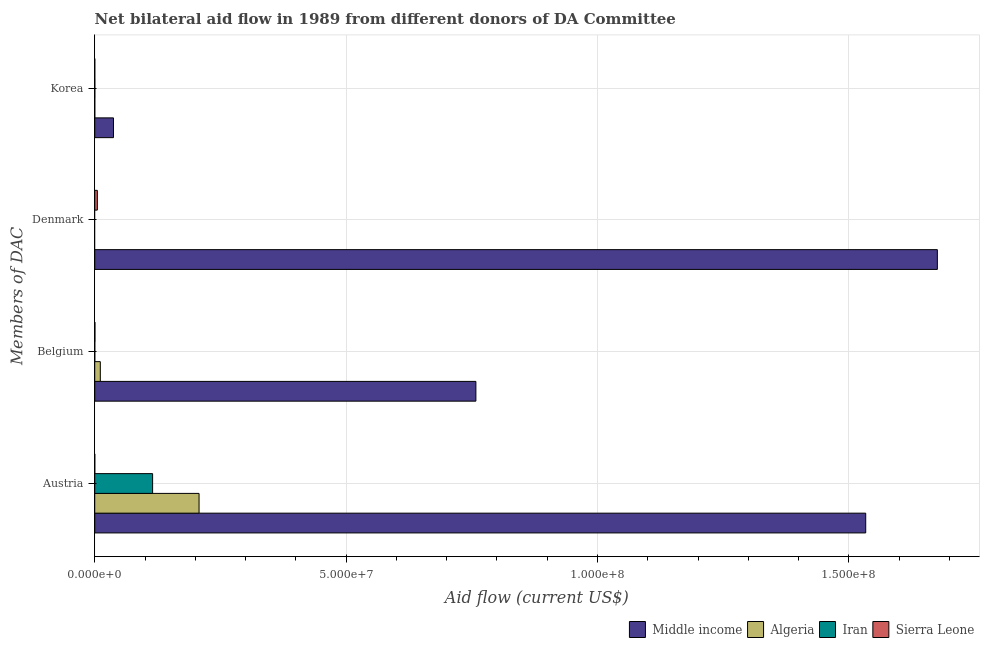How many groups of bars are there?
Ensure brevity in your answer.  4. Are the number of bars on each tick of the Y-axis equal?
Your answer should be compact. No. What is the amount of aid given by korea in Iran?
Provide a succinct answer. 2.00e+04. Across all countries, what is the maximum amount of aid given by austria?
Your response must be concise. 1.53e+08. What is the total amount of aid given by austria in the graph?
Your answer should be compact. 1.86e+08. What is the difference between the amount of aid given by belgium in Iran and that in Algeria?
Make the answer very short. -1.10e+06. What is the difference between the amount of aid given by belgium in Sierra Leone and the amount of aid given by austria in Middle income?
Provide a short and direct response. -1.53e+08. What is the average amount of aid given by belgium per country?
Provide a succinct answer. 1.92e+07. What is the difference between the amount of aid given by austria and amount of aid given by denmark in Middle income?
Make the answer very short. -1.42e+07. What is the ratio of the amount of aid given by austria in Algeria to that in Sierra Leone?
Your answer should be very brief. 2075. Is the amount of aid given by korea in Algeria less than that in Sierra Leone?
Offer a very short reply. No. What is the difference between the highest and the second highest amount of aid given by belgium?
Offer a terse response. 7.47e+07. What is the difference between the highest and the lowest amount of aid given by denmark?
Your response must be concise. 1.68e+08. In how many countries, is the amount of aid given by austria greater than the average amount of aid given by austria taken over all countries?
Make the answer very short. 1. Is the sum of the amount of aid given by belgium in Sierra Leone and Iran greater than the maximum amount of aid given by korea across all countries?
Provide a succinct answer. No. Is it the case that in every country, the sum of the amount of aid given by austria and amount of aid given by belgium is greater than the amount of aid given by denmark?
Ensure brevity in your answer.  No. How many countries are there in the graph?
Give a very brief answer. 4. Does the graph contain any zero values?
Offer a terse response. Yes. Does the graph contain grids?
Provide a succinct answer. Yes. Where does the legend appear in the graph?
Keep it short and to the point. Bottom right. How many legend labels are there?
Provide a short and direct response. 4. What is the title of the graph?
Your answer should be very brief. Net bilateral aid flow in 1989 from different donors of DA Committee. What is the label or title of the Y-axis?
Your answer should be very brief. Members of DAC. What is the Aid flow (current US$) of Middle income in Austria?
Keep it short and to the point. 1.53e+08. What is the Aid flow (current US$) of Algeria in Austria?
Provide a succinct answer. 2.08e+07. What is the Aid flow (current US$) of Iran in Austria?
Provide a short and direct response. 1.15e+07. What is the Aid flow (current US$) of Middle income in Belgium?
Ensure brevity in your answer.  7.58e+07. What is the Aid flow (current US$) in Algeria in Belgium?
Ensure brevity in your answer.  1.11e+06. What is the Aid flow (current US$) in Iran in Belgium?
Provide a short and direct response. 10000. What is the Aid flow (current US$) of Sierra Leone in Belgium?
Provide a short and direct response. 4.00e+04. What is the Aid flow (current US$) of Middle income in Denmark?
Provide a short and direct response. 1.68e+08. What is the Aid flow (current US$) in Algeria in Denmark?
Provide a short and direct response. 0. What is the Aid flow (current US$) of Iran in Denmark?
Provide a short and direct response. 0. What is the Aid flow (current US$) in Sierra Leone in Denmark?
Provide a short and direct response. 5.20e+05. What is the Aid flow (current US$) of Middle income in Korea?
Ensure brevity in your answer.  3.73e+06. What is the Aid flow (current US$) of Sierra Leone in Korea?
Give a very brief answer. 10000. Across all Members of DAC, what is the maximum Aid flow (current US$) of Middle income?
Your response must be concise. 1.68e+08. Across all Members of DAC, what is the maximum Aid flow (current US$) of Algeria?
Make the answer very short. 2.08e+07. Across all Members of DAC, what is the maximum Aid flow (current US$) in Iran?
Ensure brevity in your answer.  1.15e+07. Across all Members of DAC, what is the maximum Aid flow (current US$) of Sierra Leone?
Keep it short and to the point. 5.20e+05. Across all Members of DAC, what is the minimum Aid flow (current US$) in Middle income?
Your response must be concise. 3.73e+06. Across all Members of DAC, what is the minimum Aid flow (current US$) in Algeria?
Your answer should be very brief. 0. Across all Members of DAC, what is the minimum Aid flow (current US$) in Sierra Leone?
Offer a very short reply. 10000. What is the total Aid flow (current US$) of Middle income in the graph?
Your answer should be compact. 4.00e+08. What is the total Aid flow (current US$) of Algeria in the graph?
Make the answer very short. 2.19e+07. What is the total Aid flow (current US$) of Iran in the graph?
Offer a terse response. 1.15e+07. What is the total Aid flow (current US$) in Sierra Leone in the graph?
Make the answer very short. 5.80e+05. What is the difference between the Aid flow (current US$) in Middle income in Austria and that in Belgium?
Offer a very short reply. 7.75e+07. What is the difference between the Aid flow (current US$) in Algeria in Austria and that in Belgium?
Your answer should be very brief. 1.96e+07. What is the difference between the Aid flow (current US$) in Iran in Austria and that in Belgium?
Make the answer very short. 1.15e+07. What is the difference between the Aid flow (current US$) of Sierra Leone in Austria and that in Belgium?
Your answer should be compact. -3.00e+04. What is the difference between the Aid flow (current US$) of Middle income in Austria and that in Denmark?
Offer a terse response. -1.42e+07. What is the difference between the Aid flow (current US$) of Sierra Leone in Austria and that in Denmark?
Make the answer very short. -5.10e+05. What is the difference between the Aid flow (current US$) in Middle income in Austria and that in Korea?
Your answer should be compact. 1.50e+08. What is the difference between the Aid flow (current US$) in Algeria in Austria and that in Korea?
Give a very brief answer. 2.07e+07. What is the difference between the Aid flow (current US$) in Iran in Austria and that in Korea?
Give a very brief answer. 1.15e+07. What is the difference between the Aid flow (current US$) of Sierra Leone in Austria and that in Korea?
Keep it short and to the point. 0. What is the difference between the Aid flow (current US$) of Middle income in Belgium and that in Denmark?
Your answer should be very brief. -9.18e+07. What is the difference between the Aid flow (current US$) in Sierra Leone in Belgium and that in Denmark?
Provide a succinct answer. -4.80e+05. What is the difference between the Aid flow (current US$) in Middle income in Belgium and that in Korea?
Provide a succinct answer. 7.21e+07. What is the difference between the Aid flow (current US$) of Algeria in Belgium and that in Korea?
Your response must be concise. 1.10e+06. What is the difference between the Aid flow (current US$) of Middle income in Denmark and that in Korea?
Make the answer very short. 1.64e+08. What is the difference between the Aid flow (current US$) in Sierra Leone in Denmark and that in Korea?
Offer a very short reply. 5.10e+05. What is the difference between the Aid flow (current US$) of Middle income in Austria and the Aid flow (current US$) of Algeria in Belgium?
Your answer should be very brief. 1.52e+08. What is the difference between the Aid flow (current US$) of Middle income in Austria and the Aid flow (current US$) of Iran in Belgium?
Offer a very short reply. 1.53e+08. What is the difference between the Aid flow (current US$) in Middle income in Austria and the Aid flow (current US$) in Sierra Leone in Belgium?
Offer a very short reply. 1.53e+08. What is the difference between the Aid flow (current US$) of Algeria in Austria and the Aid flow (current US$) of Iran in Belgium?
Your answer should be very brief. 2.07e+07. What is the difference between the Aid flow (current US$) in Algeria in Austria and the Aid flow (current US$) in Sierra Leone in Belgium?
Your answer should be compact. 2.07e+07. What is the difference between the Aid flow (current US$) of Iran in Austria and the Aid flow (current US$) of Sierra Leone in Belgium?
Provide a short and direct response. 1.15e+07. What is the difference between the Aid flow (current US$) in Middle income in Austria and the Aid flow (current US$) in Sierra Leone in Denmark?
Your answer should be very brief. 1.53e+08. What is the difference between the Aid flow (current US$) of Algeria in Austria and the Aid flow (current US$) of Sierra Leone in Denmark?
Keep it short and to the point. 2.02e+07. What is the difference between the Aid flow (current US$) in Iran in Austria and the Aid flow (current US$) in Sierra Leone in Denmark?
Your response must be concise. 1.10e+07. What is the difference between the Aid flow (current US$) of Middle income in Austria and the Aid flow (current US$) of Algeria in Korea?
Your response must be concise. 1.53e+08. What is the difference between the Aid flow (current US$) in Middle income in Austria and the Aid flow (current US$) in Iran in Korea?
Your answer should be very brief. 1.53e+08. What is the difference between the Aid flow (current US$) of Middle income in Austria and the Aid flow (current US$) of Sierra Leone in Korea?
Your answer should be very brief. 1.53e+08. What is the difference between the Aid flow (current US$) of Algeria in Austria and the Aid flow (current US$) of Iran in Korea?
Keep it short and to the point. 2.07e+07. What is the difference between the Aid flow (current US$) in Algeria in Austria and the Aid flow (current US$) in Sierra Leone in Korea?
Provide a succinct answer. 2.07e+07. What is the difference between the Aid flow (current US$) in Iran in Austria and the Aid flow (current US$) in Sierra Leone in Korea?
Offer a very short reply. 1.15e+07. What is the difference between the Aid flow (current US$) of Middle income in Belgium and the Aid flow (current US$) of Sierra Leone in Denmark?
Offer a terse response. 7.53e+07. What is the difference between the Aid flow (current US$) of Algeria in Belgium and the Aid flow (current US$) of Sierra Leone in Denmark?
Keep it short and to the point. 5.90e+05. What is the difference between the Aid flow (current US$) of Iran in Belgium and the Aid flow (current US$) of Sierra Leone in Denmark?
Your response must be concise. -5.10e+05. What is the difference between the Aid flow (current US$) in Middle income in Belgium and the Aid flow (current US$) in Algeria in Korea?
Make the answer very short. 7.58e+07. What is the difference between the Aid flow (current US$) in Middle income in Belgium and the Aid flow (current US$) in Iran in Korea?
Your response must be concise. 7.58e+07. What is the difference between the Aid flow (current US$) of Middle income in Belgium and the Aid flow (current US$) of Sierra Leone in Korea?
Give a very brief answer. 7.58e+07. What is the difference between the Aid flow (current US$) in Algeria in Belgium and the Aid flow (current US$) in Iran in Korea?
Offer a terse response. 1.09e+06. What is the difference between the Aid flow (current US$) of Algeria in Belgium and the Aid flow (current US$) of Sierra Leone in Korea?
Offer a very short reply. 1.10e+06. What is the difference between the Aid flow (current US$) in Middle income in Denmark and the Aid flow (current US$) in Algeria in Korea?
Your response must be concise. 1.68e+08. What is the difference between the Aid flow (current US$) in Middle income in Denmark and the Aid flow (current US$) in Iran in Korea?
Your response must be concise. 1.68e+08. What is the difference between the Aid flow (current US$) in Middle income in Denmark and the Aid flow (current US$) in Sierra Leone in Korea?
Give a very brief answer. 1.68e+08. What is the average Aid flow (current US$) of Middle income per Members of DAC?
Ensure brevity in your answer.  1.00e+08. What is the average Aid flow (current US$) of Algeria per Members of DAC?
Your response must be concise. 5.47e+06. What is the average Aid flow (current US$) of Iran per Members of DAC?
Provide a succinct answer. 2.88e+06. What is the average Aid flow (current US$) in Sierra Leone per Members of DAC?
Ensure brevity in your answer.  1.45e+05. What is the difference between the Aid flow (current US$) in Middle income and Aid flow (current US$) in Algeria in Austria?
Keep it short and to the point. 1.33e+08. What is the difference between the Aid flow (current US$) in Middle income and Aid flow (current US$) in Iran in Austria?
Give a very brief answer. 1.42e+08. What is the difference between the Aid flow (current US$) of Middle income and Aid flow (current US$) of Sierra Leone in Austria?
Your response must be concise. 1.53e+08. What is the difference between the Aid flow (current US$) in Algeria and Aid flow (current US$) in Iran in Austria?
Ensure brevity in your answer.  9.24e+06. What is the difference between the Aid flow (current US$) in Algeria and Aid flow (current US$) in Sierra Leone in Austria?
Ensure brevity in your answer.  2.07e+07. What is the difference between the Aid flow (current US$) in Iran and Aid flow (current US$) in Sierra Leone in Austria?
Keep it short and to the point. 1.15e+07. What is the difference between the Aid flow (current US$) in Middle income and Aid flow (current US$) in Algeria in Belgium?
Your response must be concise. 7.47e+07. What is the difference between the Aid flow (current US$) of Middle income and Aid flow (current US$) of Iran in Belgium?
Provide a short and direct response. 7.58e+07. What is the difference between the Aid flow (current US$) in Middle income and Aid flow (current US$) in Sierra Leone in Belgium?
Provide a short and direct response. 7.58e+07. What is the difference between the Aid flow (current US$) of Algeria and Aid flow (current US$) of Iran in Belgium?
Offer a very short reply. 1.10e+06. What is the difference between the Aid flow (current US$) in Algeria and Aid flow (current US$) in Sierra Leone in Belgium?
Provide a succinct answer. 1.07e+06. What is the difference between the Aid flow (current US$) in Middle income and Aid flow (current US$) in Sierra Leone in Denmark?
Offer a terse response. 1.67e+08. What is the difference between the Aid flow (current US$) of Middle income and Aid flow (current US$) of Algeria in Korea?
Ensure brevity in your answer.  3.72e+06. What is the difference between the Aid flow (current US$) of Middle income and Aid flow (current US$) of Iran in Korea?
Your response must be concise. 3.71e+06. What is the difference between the Aid flow (current US$) of Middle income and Aid flow (current US$) of Sierra Leone in Korea?
Give a very brief answer. 3.72e+06. What is the difference between the Aid flow (current US$) of Algeria and Aid flow (current US$) of Iran in Korea?
Ensure brevity in your answer.  -10000. What is the ratio of the Aid flow (current US$) of Middle income in Austria to that in Belgium?
Offer a very short reply. 2.02. What is the ratio of the Aid flow (current US$) of Algeria in Austria to that in Belgium?
Ensure brevity in your answer.  18.69. What is the ratio of the Aid flow (current US$) in Iran in Austria to that in Belgium?
Make the answer very short. 1151. What is the ratio of the Aid flow (current US$) in Middle income in Austria to that in Denmark?
Your response must be concise. 0.92. What is the ratio of the Aid flow (current US$) of Sierra Leone in Austria to that in Denmark?
Provide a succinct answer. 0.02. What is the ratio of the Aid flow (current US$) of Middle income in Austria to that in Korea?
Your answer should be compact. 41.11. What is the ratio of the Aid flow (current US$) in Algeria in Austria to that in Korea?
Ensure brevity in your answer.  2075. What is the ratio of the Aid flow (current US$) of Iran in Austria to that in Korea?
Provide a succinct answer. 575.5. What is the ratio of the Aid flow (current US$) in Middle income in Belgium to that in Denmark?
Your answer should be very brief. 0.45. What is the ratio of the Aid flow (current US$) of Sierra Leone in Belgium to that in Denmark?
Make the answer very short. 0.08. What is the ratio of the Aid flow (current US$) of Middle income in Belgium to that in Korea?
Offer a terse response. 20.32. What is the ratio of the Aid flow (current US$) in Algeria in Belgium to that in Korea?
Provide a short and direct response. 111. What is the ratio of the Aid flow (current US$) in Sierra Leone in Belgium to that in Korea?
Your answer should be very brief. 4. What is the ratio of the Aid flow (current US$) in Middle income in Denmark to that in Korea?
Provide a short and direct response. 44.93. What is the difference between the highest and the second highest Aid flow (current US$) of Middle income?
Offer a terse response. 1.42e+07. What is the difference between the highest and the second highest Aid flow (current US$) of Algeria?
Offer a terse response. 1.96e+07. What is the difference between the highest and the second highest Aid flow (current US$) of Iran?
Your answer should be compact. 1.15e+07. What is the difference between the highest and the lowest Aid flow (current US$) in Middle income?
Make the answer very short. 1.64e+08. What is the difference between the highest and the lowest Aid flow (current US$) in Algeria?
Ensure brevity in your answer.  2.08e+07. What is the difference between the highest and the lowest Aid flow (current US$) of Iran?
Offer a very short reply. 1.15e+07. What is the difference between the highest and the lowest Aid flow (current US$) in Sierra Leone?
Make the answer very short. 5.10e+05. 